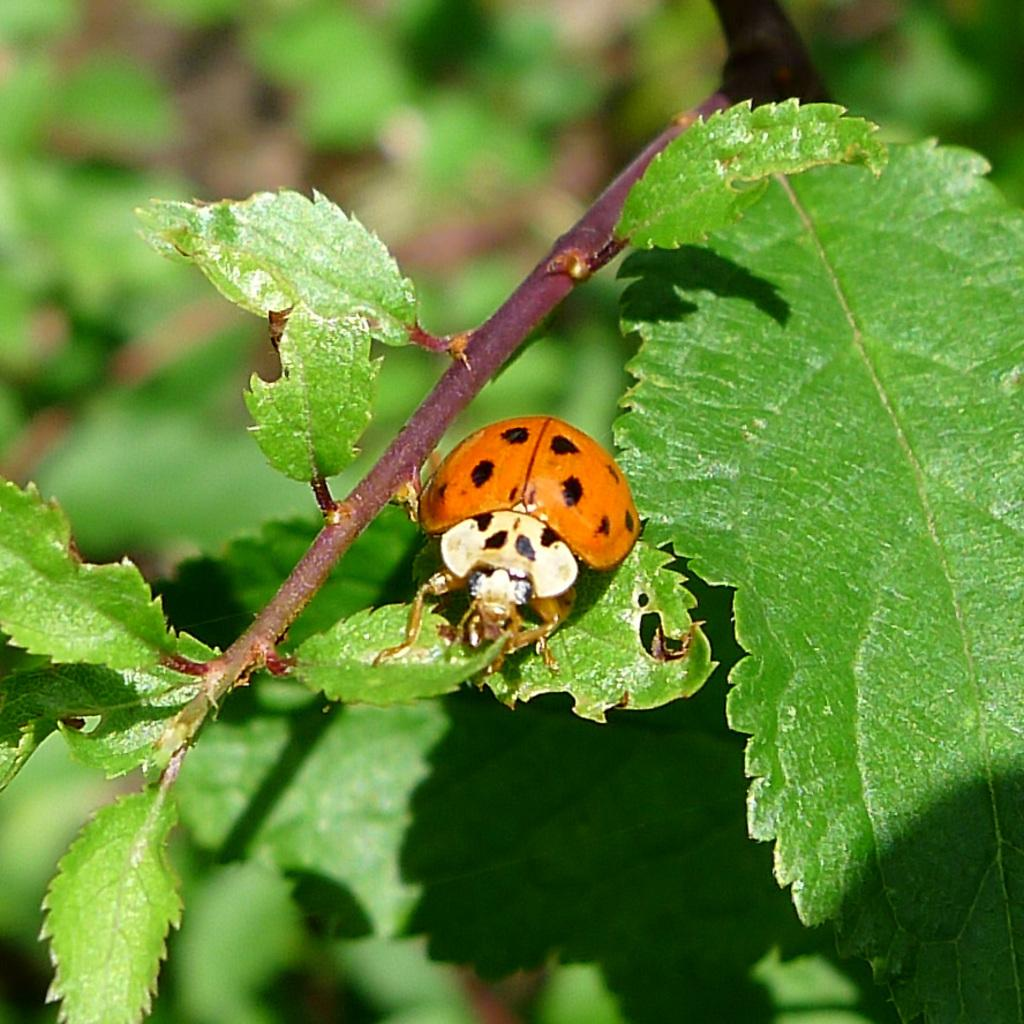What is the main subject in the center of the image? There is a branch with leaves in the center of the image. Can you describe any living organisms on the branch? Yes, there is an insect on one of the leaves. What colors can be seen on the insect? The insect has orange and black colors. What can be seen in the background of the image? There are trees visible in the background of the image. What type of honey is being produced by the insect in the image? There is no honey production mentioned or visible in the image; it features a branch with leaves and an insect. In which direction is the stove located in the image? There is no stove present in the image. 